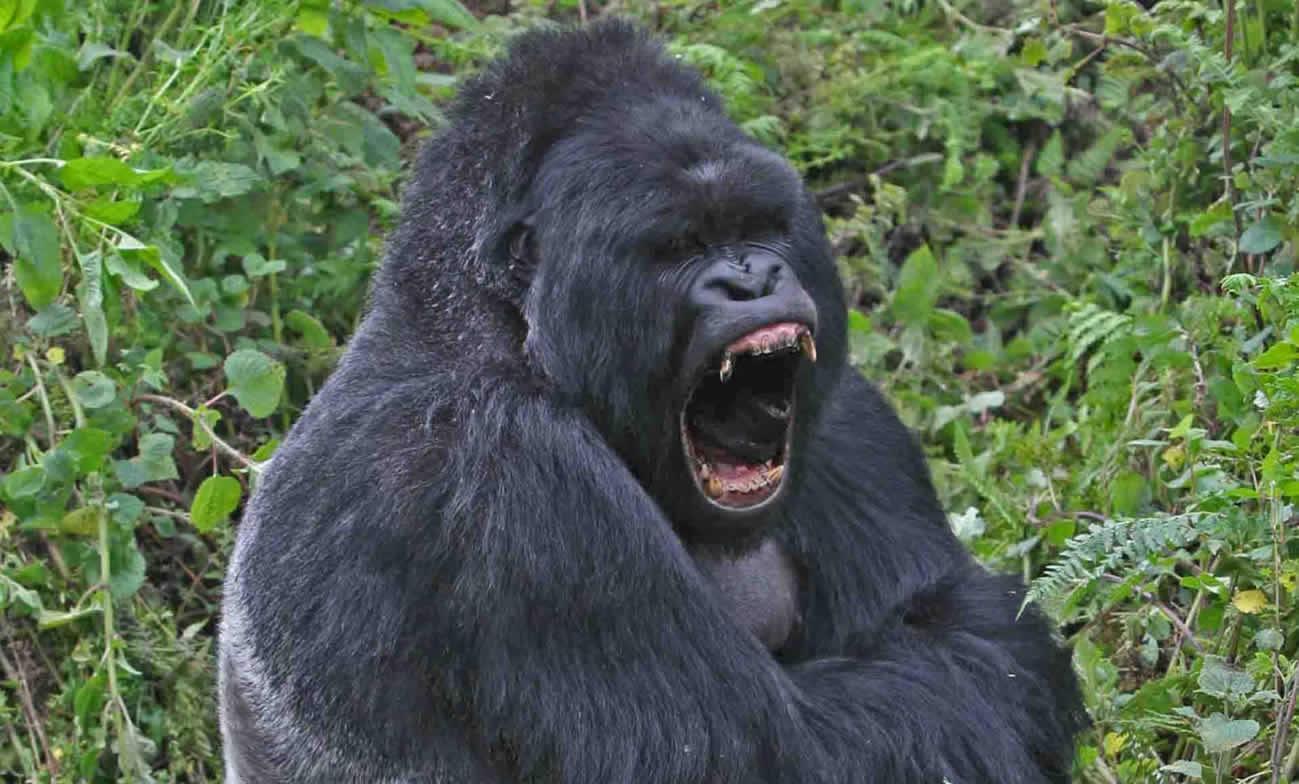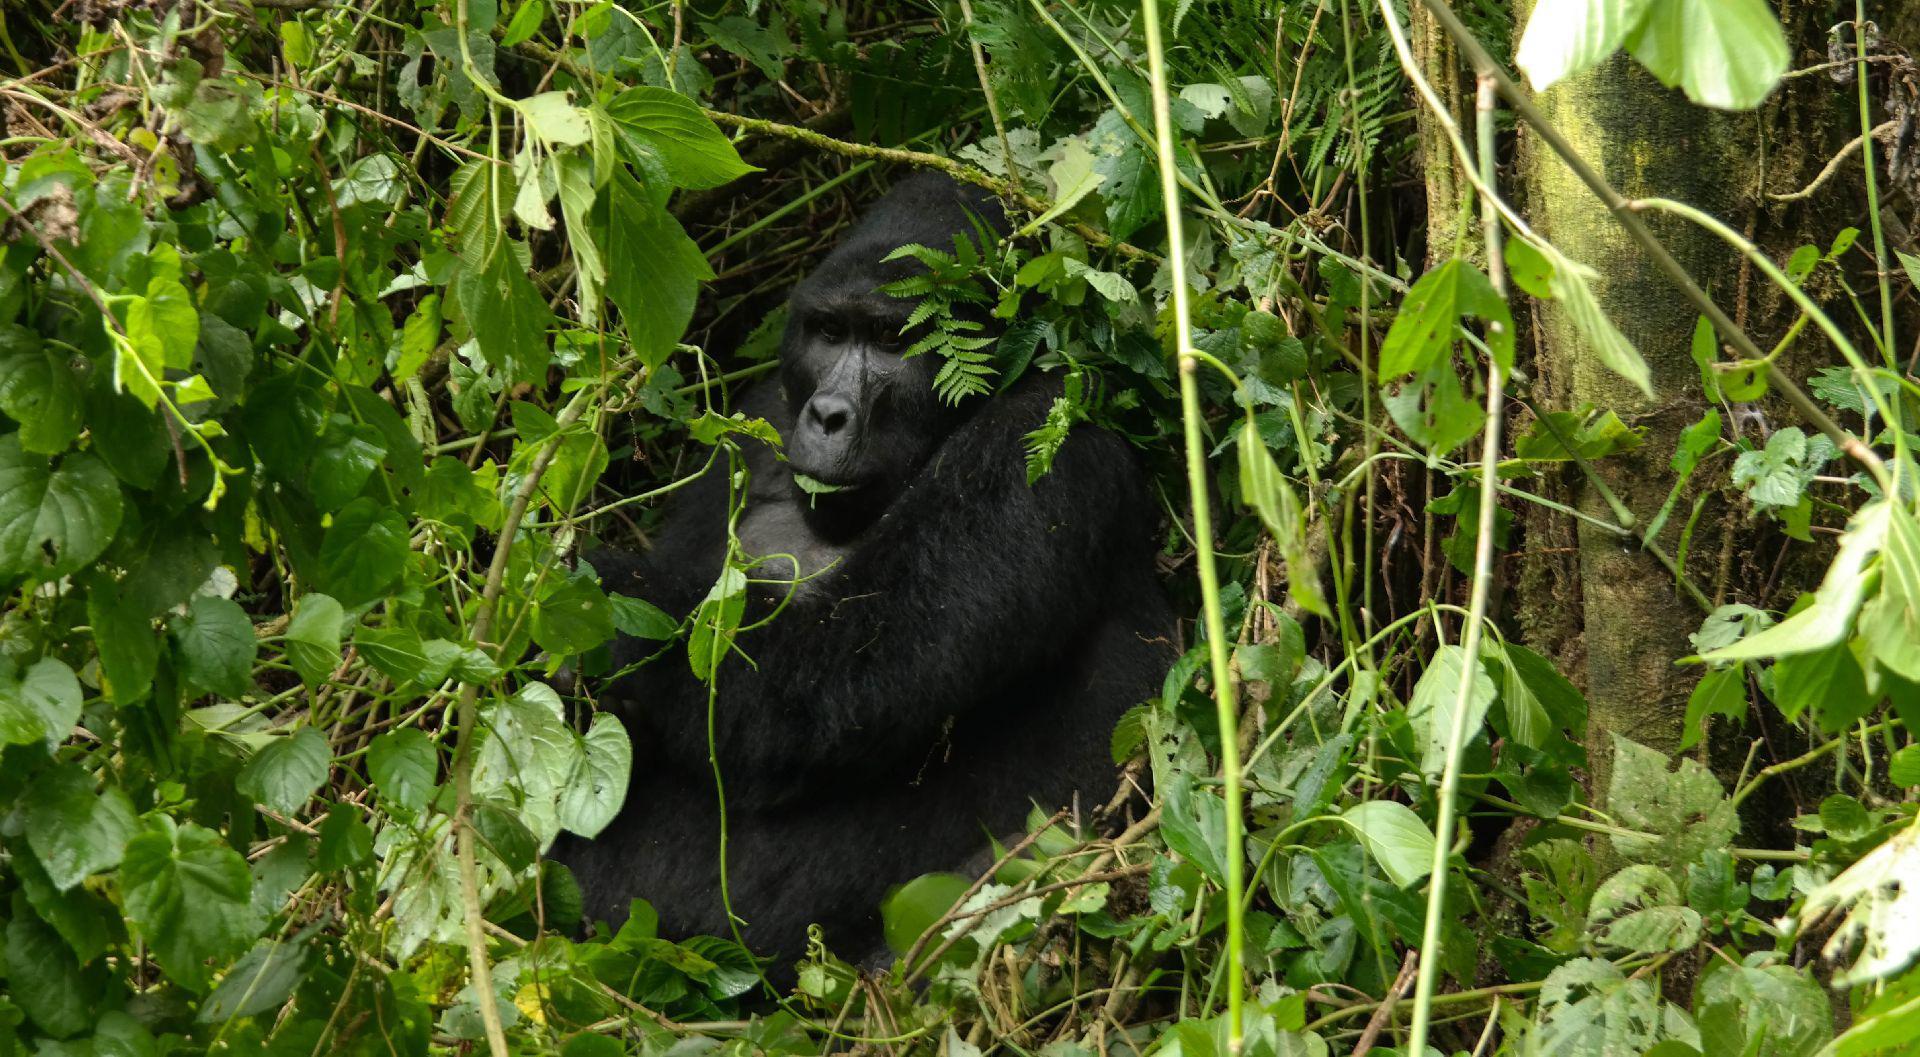The first image is the image on the left, the second image is the image on the right. Considering the images on both sides, is "There are two gorillas in the pair of images." valid? Answer yes or no. Yes. The first image is the image on the left, the second image is the image on the right. For the images shown, is this caption "The left image contains exactly one gorilla." true? Answer yes or no. Yes. 